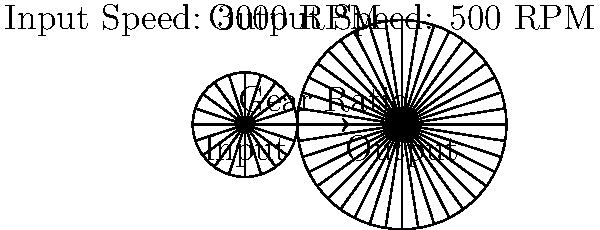Given a gearbox system with an input speed of 3000 RPM and a desired output speed of 500 RPM, determine the optimal gear ratio. How would this ratio affect the torque transfer in the system? To solve this problem, we'll follow these steps:

1. Calculate the gear ratio:
   The gear ratio is defined as the ratio of input speed to output speed.
   
   $$ \text{Gear Ratio} = \frac{\text{Input Speed}}{\text{Output Speed}} $$
   
   $$ \text{Gear Ratio} = \frac{3000 \text{ RPM}}{500 \text{ RPM}} = 6:1 $$

2. Interpret the gear ratio:
   A 6:1 gear ratio means that for every 6 rotations of the input gear, the output gear rotates once.

3. Effect on torque:
   The gear ratio affects torque transfer inversely to speed. We can calculate this using the principle of conservation of energy:

   $$ \text{Input Power} = \text{Output Power} $$
   $$ \text{Input Torque} \times \text{Input Speed} = \text{Output Torque} \times \text{Output Speed} $$

   Rearranging this equation:

   $$ \frac{\text{Output Torque}}{\text{Input Torque}} = \frac{\text{Input Speed}}{\text{Output Speed}} = \text{Gear Ratio} $$

   Therefore, the output torque will be 6 times the input torque.

4. Conclusion:
   The optimal gear ratio for this system is 6:1. This ratio will reduce the speed by a factor of 6 and increase the torque by a factor of 6, assuming 100% efficiency (which is not realistic in practice due to friction and other losses).
Answer: 6:1 ratio; increases output torque 6-fold 